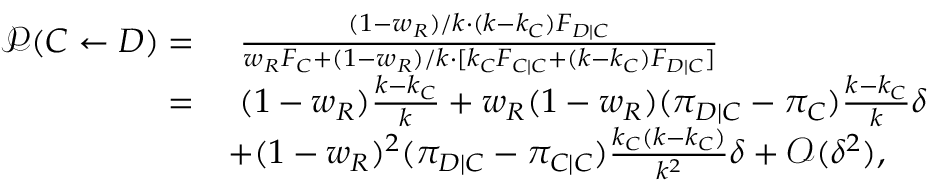Convert formula to latex. <formula><loc_0><loc_0><loc_500><loc_500>\begin{array} { r l } { \mathcal { P } ( C \gets D ) = } & { \frac { ( 1 - w _ { R } ) / k \cdot ( k - k _ { C } ) F _ { D | C } } { w _ { R } F _ { C } + ( 1 - w _ { R } ) / k \cdot [ k _ { C } F _ { C | C } + ( k - k _ { C } ) F _ { D | C } ] } } \\ { = } & { ( 1 - w _ { R } ) \frac { k - k _ { C } } { k } + w _ { R } ( 1 - w _ { R } ) ( \pi _ { D | C } - \pi _ { C } ) \frac { k - k _ { C } } { k } \delta } \\ & { + ( 1 - w _ { R } ) ^ { 2 } ( \pi _ { D | C } - \pi _ { C | C } ) \frac { k _ { C } ( k - k _ { C } ) } { k ^ { 2 } } \delta + \mathcal { O } ( \delta ^ { 2 } ) , } \end{array}</formula> 